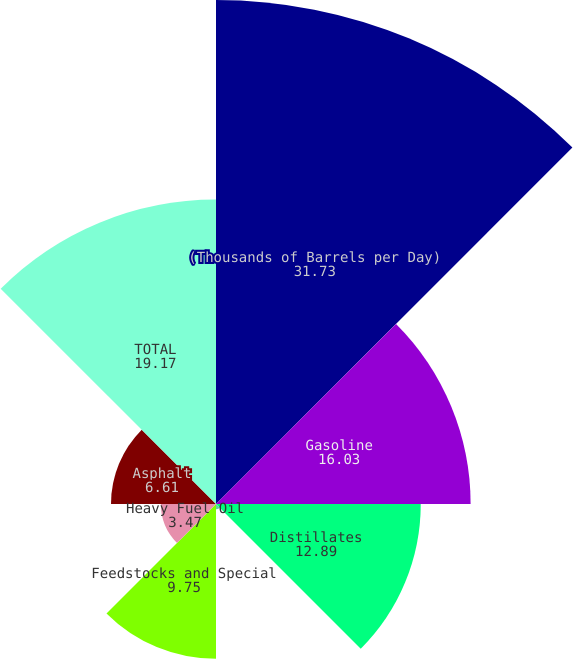<chart> <loc_0><loc_0><loc_500><loc_500><pie_chart><fcel>(Thousands of Barrels per Day)<fcel>Gasoline<fcel>Distillates<fcel>Propane<fcel>Feedstocks and Special<fcel>Heavy Fuel Oil<fcel>Asphalt<fcel>TOTAL<nl><fcel>31.73%<fcel>16.03%<fcel>12.89%<fcel>0.33%<fcel>9.75%<fcel>3.47%<fcel>6.61%<fcel>19.17%<nl></chart> 